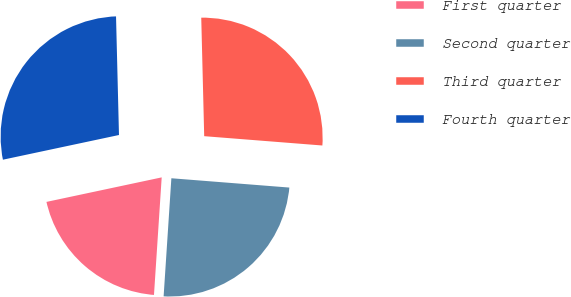<chart> <loc_0><loc_0><loc_500><loc_500><pie_chart><fcel>First quarter<fcel>Second quarter<fcel>Third quarter<fcel>Fourth quarter<nl><fcel>20.62%<fcel>24.79%<fcel>26.65%<fcel>27.94%<nl></chart> 